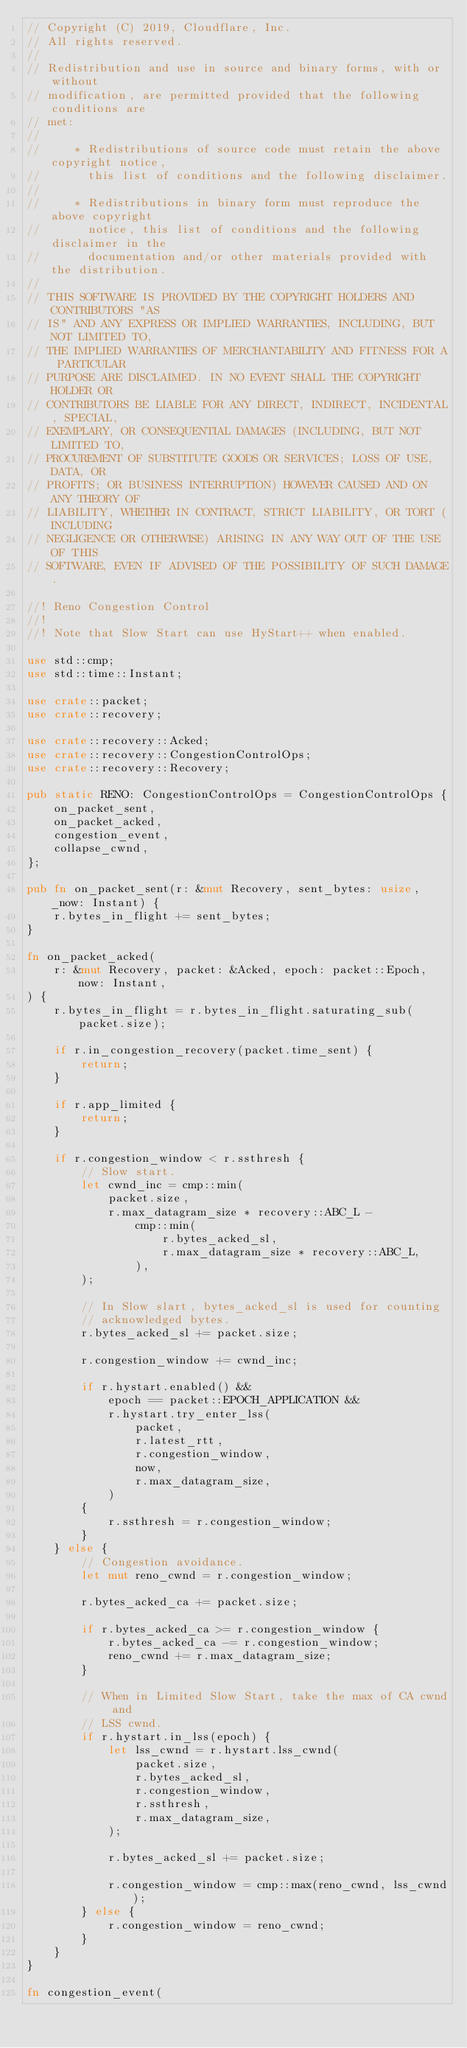<code> <loc_0><loc_0><loc_500><loc_500><_Rust_>// Copyright (C) 2019, Cloudflare, Inc.
// All rights reserved.
//
// Redistribution and use in source and binary forms, with or without
// modification, are permitted provided that the following conditions are
// met:
//
//     * Redistributions of source code must retain the above copyright notice,
//       this list of conditions and the following disclaimer.
//
//     * Redistributions in binary form must reproduce the above copyright
//       notice, this list of conditions and the following disclaimer in the
//       documentation and/or other materials provided with the distribution.
//
// THIS SOFTWARE IS PROVIDED BY THE COPYRIGHT HOLDERS AND CONTRIBUTORS "AS
// IS" AND ANY EXPRESS OR IMPLIED WARRANTIES, INCLUDING, BUT NOT LIMITED TO,
// THE IMPLIED WARRANTIES OF MERCHANTABILITY AND FITNESS FOR A PARTICULAR
// PURPOSE ARE DISCLAIMED. IN NO EVENT SHALL THE COPYRIGHT HOLDER OR
// CONTRIBUTORS BE LIABLE FOR ANY DIRECT, INDIRECT, INCIDENTAL, SPECIAL,
// EXEMPLARY, OR CONSEQUENTIAL DAMAGES (INCLUDING, BUT NOT LIMITED TO,
// PROCUREMENT OF SUBSTITUTE GOODS OR SERVICES; LOSS OF USE, DATA, OR
// PROFITS; OR BUSINESS INTERRUPTION) HOWEVER CAUSED AND ON ANY THEORY OF
// LIABILITY, WHETHER IN CONTRACT, STRICT LIABILITY, OR TORT (INCLUDING
// NEGLIGENCE OR OTHERWISE) ARISING IN ANY WAY OUT OF THE USE OF THIS
// SOFTWARE, EVEN IF ADVISED OF THE POSSIBILITY OF SUCH DAMAGE.

//! Reno Congestion Control
//!
//! Note that Slow Start can use HyStart++ when enabled.

use std::cmp;
use std::time::Instant;

use crate::packet;
use crate::recovery;

use crate::recovery::Acked;
use crate::recovery::CongestionControlOps;
use crate::recovery::Recovery;

pub static RENO: CongestionControlOps = CongestionControlOps {
    on_packet_sent,
    on_packet_acked,
    congestion_event,
    collapse_cwnd,
};

pub fn on_packet_sent(r: &mut Recovery, sent_bytes: usize, _now: Instant) {
    r.bytes_in_flight += sent_bytes;
}

fn on_packet_acked(
    r: &mut Recovery, packet: &Acked, epoch: packet::Epoch, now: Instant,
) {
    r.bytes_in_flight = r.bytes_in_flight.saturating_sub(packet.size);

    if r.in_congestion_recovery(packet.time_sent) {
        return;
    }

    if r.app_limited {
        return;
    }

    if r.congestion_window < r.ssthresh {
        // Slow start.
        let cwnd_inc = cmp::min(
            packet.size,
            r.max_datagram_size * recovery::ABC_L -
                cmp::min(
                    r.bytes_acked_sl,
                    r.max_datagram_size * recovery::ABC_L,
                ),
        );

        // In Slow slart, bytes_acked_sl is used for counting
        // acknowledged bytes.
        r.bytes_acked_sl += packet.size;

        r.congestion_window += cwnd_inc;

        if r.hystart.enabled() &&
            epoch == packet::EPOCH_APPLICATION &&
            r.hystart.try_enter_lss(
                packet,
                r.latest_rtt,
                r.congestion_window,
                now,
                r.max_datagram_size,
            )
        {
            r.ssthresh = r.congestion_window;
        }
    } else {
        // Congestion avoidance.
        let mut reno_cwnd = r.congestion_window;

        r.bytes_acked_ca += packet.size;

        if r.bytes_acked_ca >= r.congestion_window {
            r.bytes_acked_ca -= r.congestion_window;
            reno_cwnd += r.max_datagram_size;
        }

        // When in Limited Slow Start, take the max of CA cwnd and
        // LSS cwnd.
        if r.hystart.in_lss(epoch) {
            let lss_cwnd = r.hystart.lss_cwnd(
                packet.size,
                r.bytes_acked_sl,
                r.congestion_window,
                r.ssthresh,
                r.max_datagram_size,
            );

            r.bytes_acked_sl += packet.size;

            r.congestion_window = cmp::max(reno_cwnd, lss_cwnd);
        } else {
            r.congestion_window = reno_cwnd;
        }
    }
}

fn congestion_event(</code> 